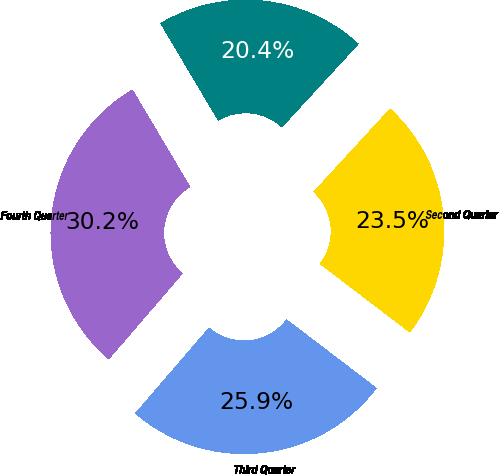Convert chart to OTSL. <chart><loc_0><loc_0><loc_500><loc_500><pie_chart><fcel>First Quarter<fcel>Second Quarter<fcel>Third Quarter<fcel>Fourth Quarter<nl><fcel>20.36%<fcel>23.53%<fcel>25.95%<fcel>30.16%<nl></chart> 